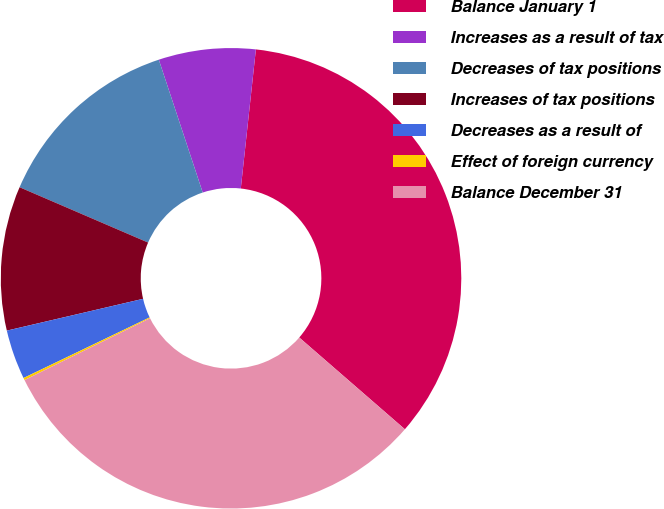<chart> <loc_0><loc_0><loc_500><loc_500><pie_chart><fcel>Balance January 1<fcel>Increases as a result of tax<fcel>Decreases of tax positions<fcel>Increases of tax positions<fcel>Decreases as a result of<fcel>Effect of foreign currency<fcel>Balance December 31<nl><fcel>34.66%<fcel>6.8%<fcel>13.45%<fcel>10.12%<fcel>3.48%<fcel>0.16%<fcel>31.33%<nl></chart> 